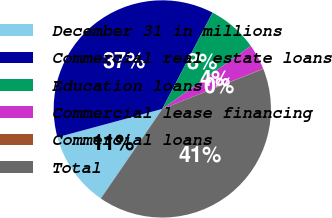Convert chart. <chart><loc_0><loc_0><loc_500><loc_500><pie_chart><fcel>December 31 in millions<fcel>Commercial real estate loans<fcel>Education loans<fcel>Commercial lease financing<fcel>Commercial loans<fcel>Total<nl><fcel>11.23%<fcel>36.85%<fcel>7.51%<fcel>3.78%<fcel>0.06%<fcel>40.57%<nl></chart> 